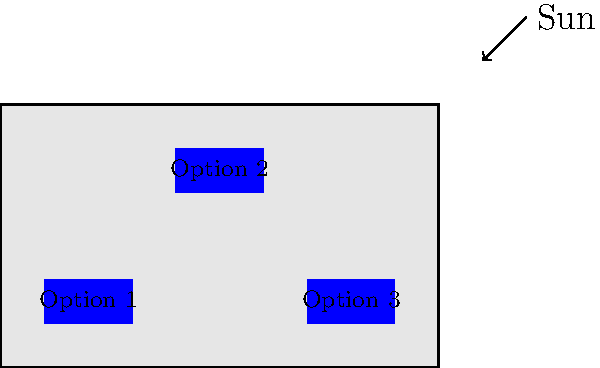Given the factory roof layout and sun position shown in the diagram, which solar panel placement option (1, 2, or 3) would likely yield the highest energy capture throughout the day? To determine the optimal solar panel placement for maximum energy capture, we need to consider several factors:

1. Sun position: The diagram shows the sun's position in the upper right corner, indicating it's likely in the southern sky (assuming this is in the northern hemisphere).

2. Panel angle: Flat panels are shown, so we'll assume they can't be tilted.

3. Roof obstructions: The roof appears clear of obstructions.

4. Panel positions:
   - Option 1: Lower left corner
   - Option 2: Center of the roof
   - Option 3: Lower right corner

Considering these factors:

1. Southern exposure: In the northern hemisphere, south-facing panels receive the most sunlight throughout the day.

2. Shade avoidance: Panels should be placed where they're least likely to be shaded by nearby structures or other panels.

3. Even distribution: Spreading panels across the roof can help capture sunlight at different times of the day.

Option 2 is the most favorable because:
- It's centrally located, which helps avoid potential shading from roof edges or nearby structures.
- It's higher on the roof, which generally means better exposure to sunlight throughout the day.
- Its position allows for potential expansion in multiple directions if more panels are added later.

Options 1 and 3 are less optimal because they're lower on the roof and closer to the edges, which may result in more shading and less consistent sunlight exposure.
Answer: Option 2 